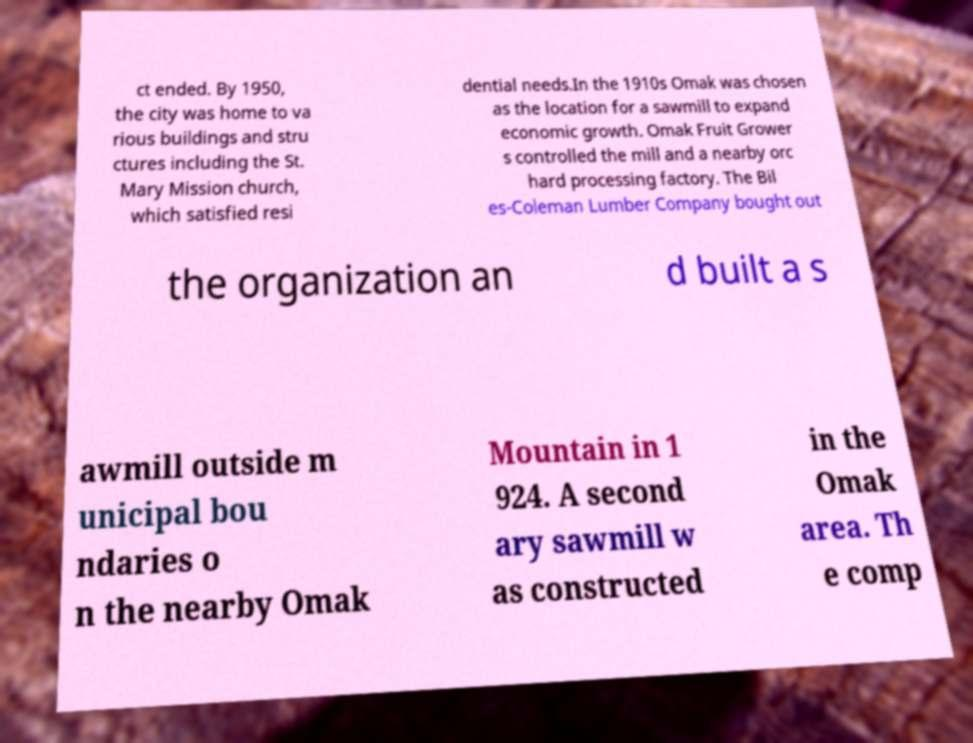Could you assist in decoding the text presented in this image and type it out clearly? ct ended. By 1950, the city was home to va rious buildings and stru ctures including the St. Mary Mission church, which satisfied resi dential needs.In the 1910s Omak was chosen as the location for a sawmill to expand economic growth. Omak Fruit Grower s controlled the mill and a nearby orc hard processing factory. The Bil es-Coleman Lumber Company bought out the organization an d built a s awmill outside m unicipal bou ndaries o n the nearby Omak Mountain in 1 924. A second ary sawmill w as constructed in the Omak area. Th e comp 